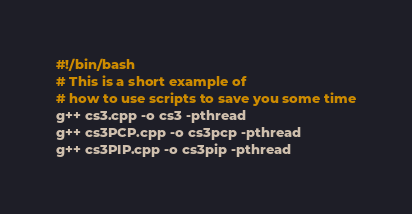Convert code to text. <code><loc_0><loc_0><loc_500><loc_500><_Bash_>#!/bin/bash
# This is a short example of
# how to use scripts to save you some time
g++ cs3.cpp -o cs3 -pthread
g++ cs3PCP.cpp -o cs3pcp -pthread
g++ cs3PIP.cpp -o cs3pip -pthread
</code> 